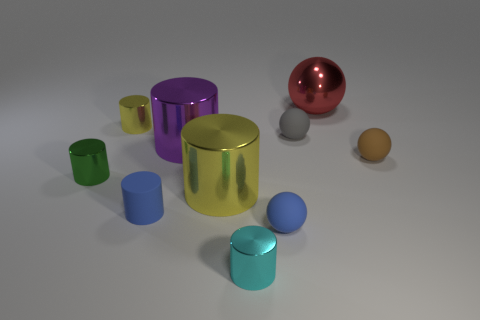Subtract all cylinders. Subtract all small gray balls. How many objects are left? 3 Add 8 yellow shiny things. How many yellow shiny things are left? 10 Add 1 purple objects. How many purple objects exist? 2 Subtract all cyan cylinders. How many cylinders are left? 5 Subtract all small rubber balls. How many balls are left? 1 Subtract 1 brown spheres. How many objects are left? 9 Subtract all balls. How many objects are left? 6 Subtract 4 cylinders. How many cylinders are left? 2 Subtract all yellow spheres. Subtract all blue cylinders. How many spheres are left? 4 Subtract all yellow cubes. How many red balls are left? 1 